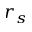Convert formula to latex. <formula><loc_0><loc_0><loc_500><loc_500>r _ { s }</formula> 